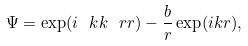Convert formula to latex. <formula><loc_0><loc_0><loc_500><loc_500>\Psi = \exp ( i \ k k \ r r ) - \frac { b } { r } \exp ( i k r ) ,</formula> 